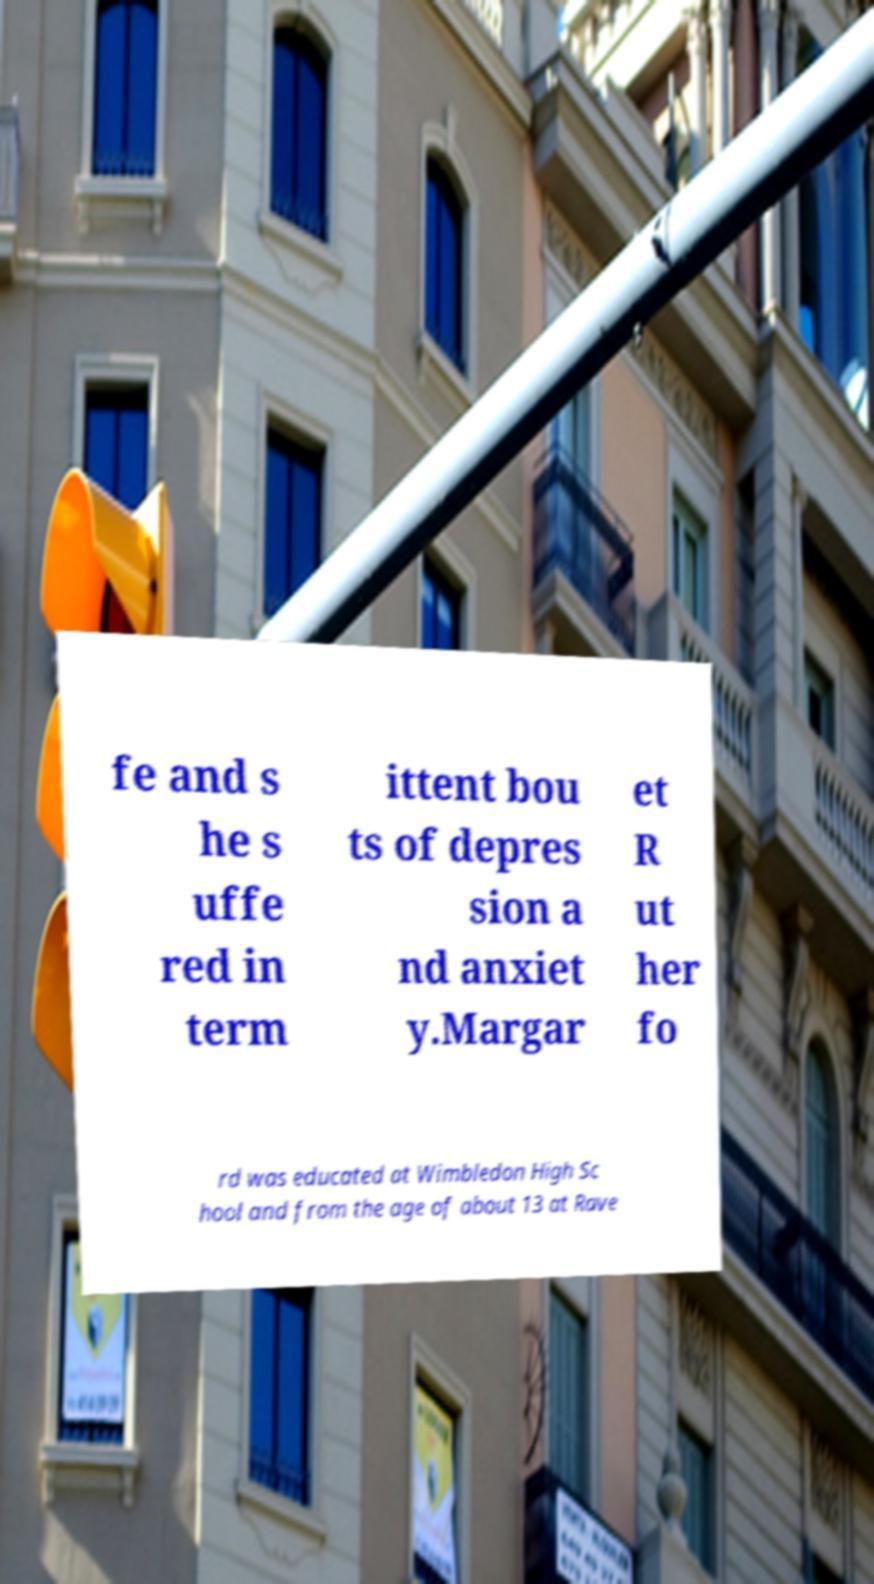Could you assist in decoding the text presented in this image and type it out clearly? fe and s he s uffe red in term ittent bou ts of depres sion a nd anxiet y.Margar et R ut her fo rd was educated at Wimbledon High Sc hool and from the age of about 13 at Rave 